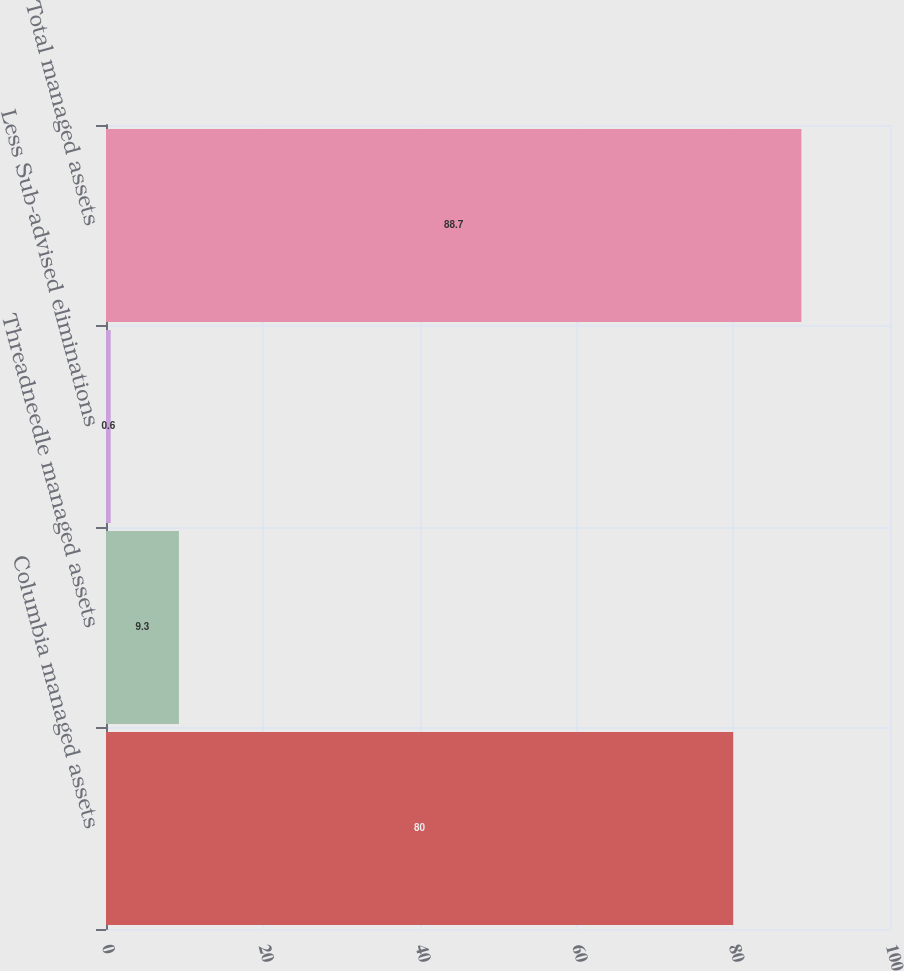Convert chart. <chart><loc_0><loc_0><loc_500><loc_500><bar_chart><fcel>Columbia managed assets<fcel>Threadneedle managed assets<fcel>Less Sub-advised eliminations<fcel>Total managed assets<nl><fcel>80<fcel>9.3<fcel>0.6<fcel>88.7<nl></chart> 